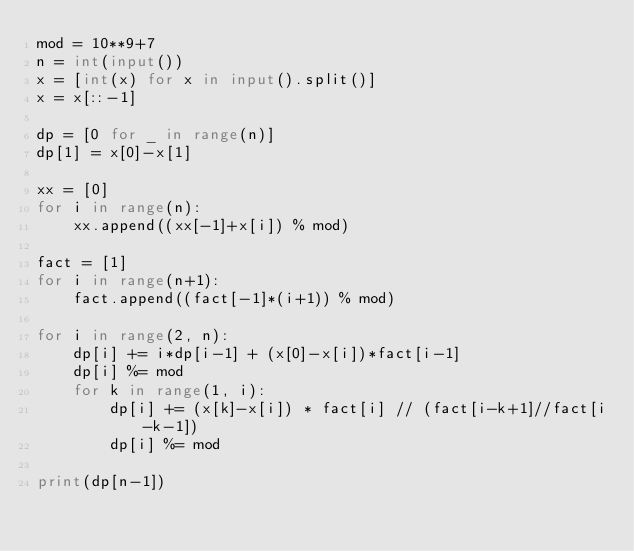Convert code to text. <code><loc_0><loc_0><loc_500><loc_500><_Python_>mod = 10**9+7
n = int(input())
x = [int(x) for x in input().split()]
x = x[::-1]

dp = [0 for _ in range(n)]
dp[1] = x[0]-x[1]

xx = [0]
for i in range(n):
    xx.append((xx[-1]+x[i]) % mod)

fact = [1]
for i in range(n+1):
    fact.append((fact[-1]*(i+1)) % mod)

for i in range(2, n):
    dp[i] += i*dp[i-1] + (x[0]-x[i])*fact[i-1]
    dp[i] %= mod
    for k in range(1, i):
        dp[i] += (x[k]-x[i]) * fact[i] // (fact[i-k+1]//fact[i-k-1])
        dp[i] %= mod

print(dp[n-1])
</code> 